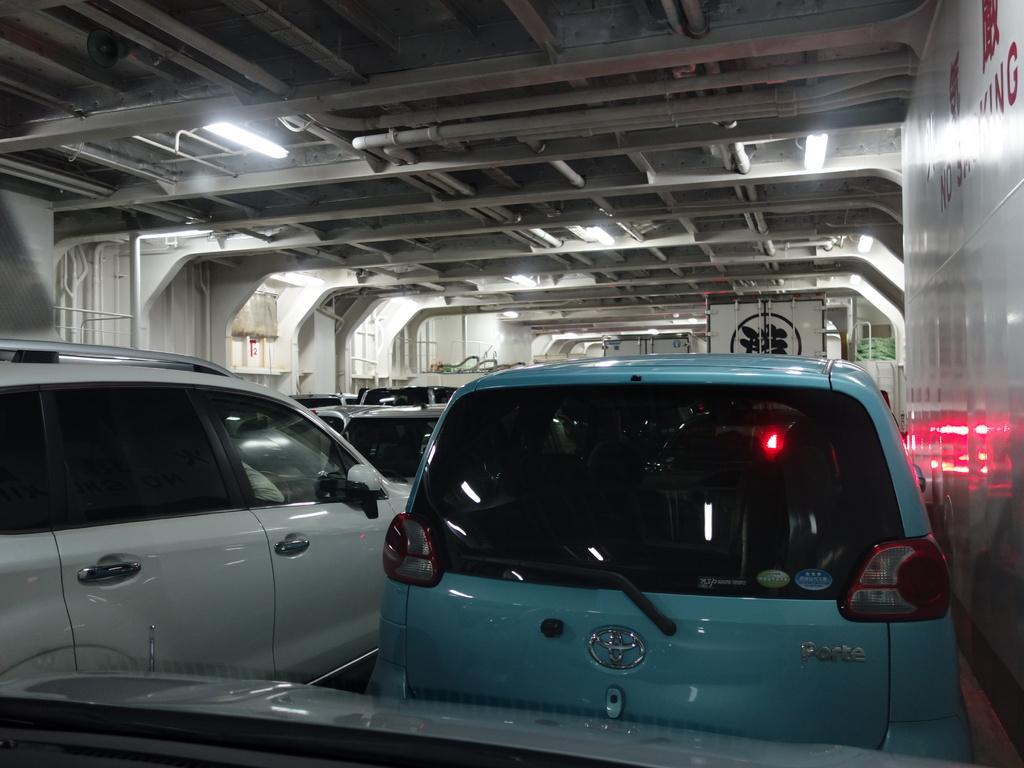Please provide a concise description of this image. There are cars under a shed. Here we can see lights and roof. 